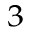<formula> <loc_0><loc_0><loc_500><loc_500>^ { 3 }</formula> 